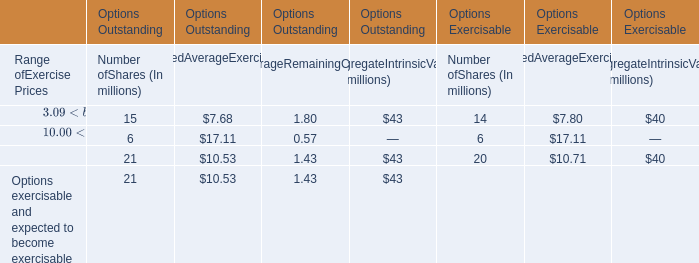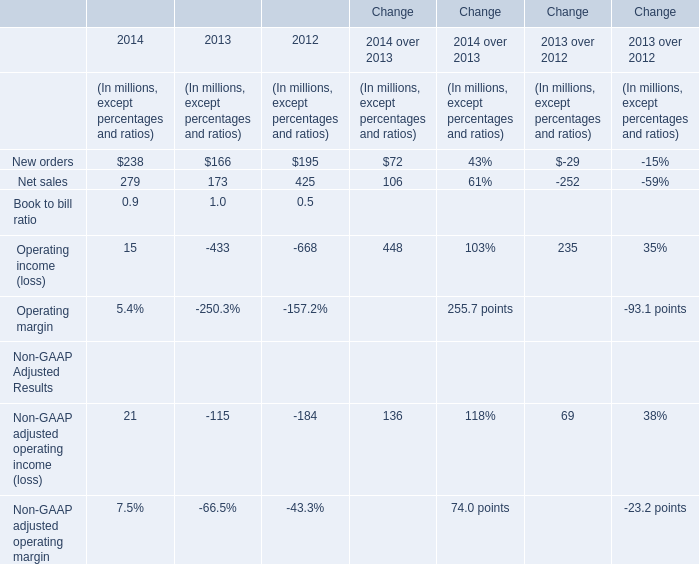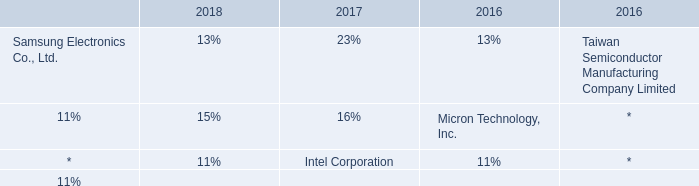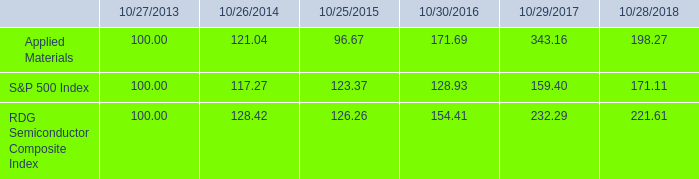What's the total amount of new orders ,net sales, Non-GAAP adjusted operating income and Operating income in 2014? (in million) 
Computations: (((238 + 279) + 21) + 15)
Answer: 553.0. 